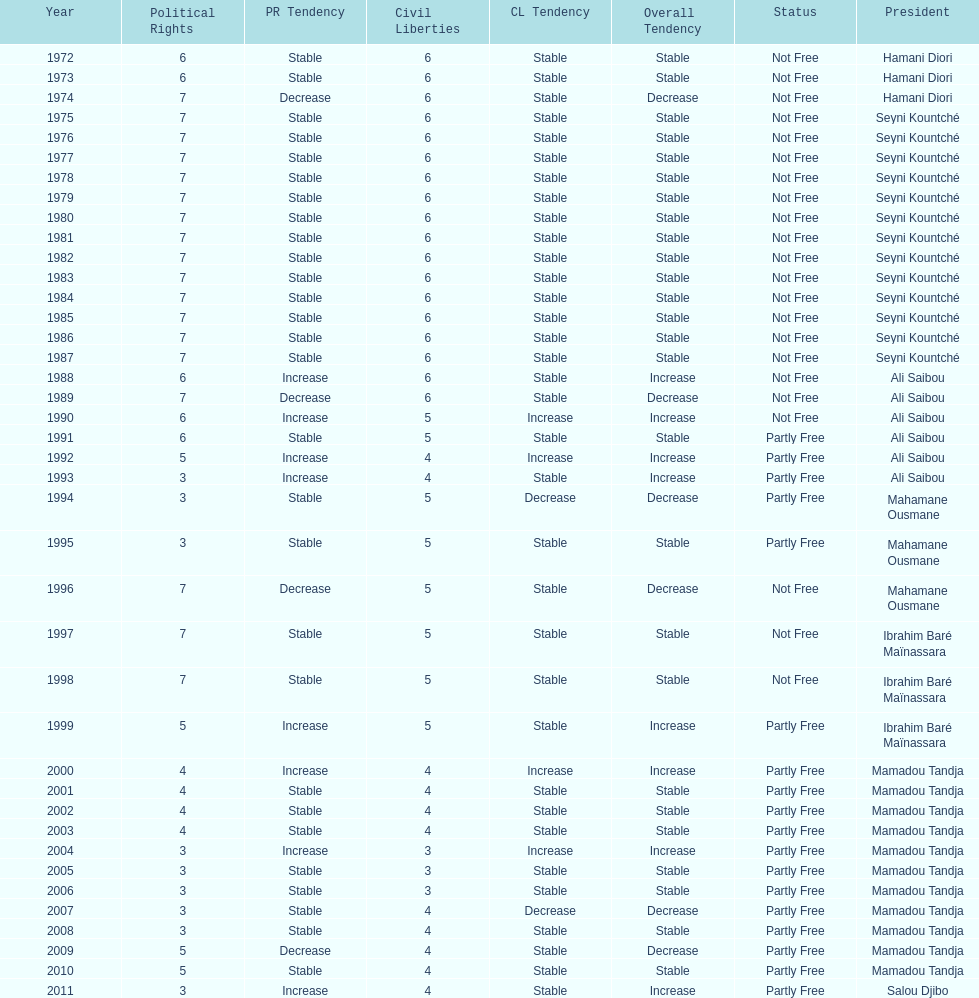Who ruled longer, ali saibou or mamadou tandja? Mamadou Tandja. 